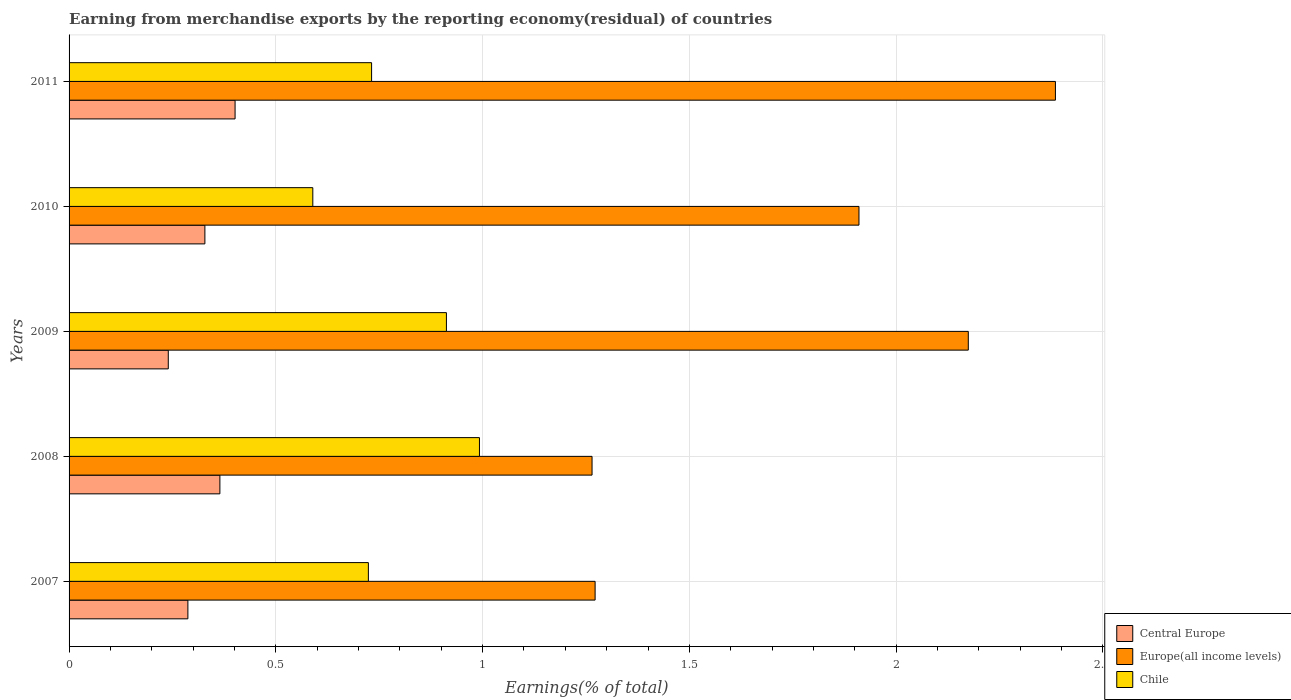How many different coloured bars are there?
Keep it short and to the point. 3. How many groups of bars are there?
Provide a short and direct response. 5. Are the number of bars on each tick of the Y-axis equal?
Ensure brevity in your answer.  Yes. How many bars are there on the 3rd tick from the bottom?
Provide a succinct answer. 3. What is the percentage of amount earned from merchandise exports in Europe(all income levels) in 2008?
Offer a very short reply. 1.26. Across all years, what is the maximum percentage of amount earned from merchandise exports in Central Europe?
Offer a terse response. 0.4. Across all years, what is the minimum percentage of amount earned from merchandise exports in Europe(all income levels)?
Give a very brief answer. 1.26. In which year was the percentage of amount earned from merchandise exports in Central Europe maximum?
Keep it short and to the point. 2011. In which year was the percentage of amount earned from merchandise exports in Central Europe minimum?
Provide a short and direct response. 2009. What is the total percentage of amount earned from merchandise exports in Central Europe in the graph?
Offer a very short reply. 1.62. What is the difference between the percentage of amount earned from merchandise exports in Europe(all income levels) in 2009 and that in 2010?
Offer a terse response. 0.26. What is the difference between the percentage of amount earned from merchandise exports in Europe(all income levels) in 2010 and the percentage of amount earned from merchandise exports in Chile in 2008?
Make the answer very short. 0.92. What is the average percentage of amount earned from merchandise exports in Central Europe per year?
Your answer should be very brief. 0.32. In the year 2011, what is the difference between the percentage of amount earned from merchandise exports in Chile and percentage of amount earned from merchandise exports in Central Europe?
Offer a very short reply. 0.33. In how many years, is the percentage of amount earned from merchandise exports in Europe(all income levels) greater than 0.7 %?
Make the answer very short. 5. What is the ratio of the percentage of amount earned from merchandise exports in Europe(all income levels) in 2009 to that in 2010?
Your response must be concise. 1.14. Is the percentage of amount earned from merchandise exports in Central Europe in 2009 less than that in 2010?
Provide a short and direct response. Yes. What is the difference between the highest and the second highest percentage of amount earned from merchandise exports in Central Europe?
Your answer should be compact. 0.04. What is the difference between the highest and the lowest percentage of amount earned from merchandise exports in Europe(all income levels)?
Ensure brevity in your answer.  1.12. In how many years, is the percentage of amount earned from merchandise exports in Central Europe greater than the average percentage of amount earned from merchandise exports in Central Europe taken over all years?
Keep it short and to the point. 3. Is the sum of the percentage of amount earned from merchandise exports in Chile in 2010 and 2011 greater than the maximum percentage of amount earned from merchandise exports in Europe(all income levels) across all years?
Your response must be concise. No. What does the 1st bar from the top in 2011 represents?
Keep it short and to the point. Chile. What does the 2nd bar from the bottom in 2007 represents?
Keep it short and to the point. Europe(all income levels). Is it the case that in every year, the sum of the percentage of amount earned from merchandise exports in Europe(all income levels) and percentage of amount earned from merchandise exports in Chile is greater than the percentage of amount earned from merchandise exports in Central Europe?
Give a very brief answer. Yes. Are all the bars in the graph horizontal?
Give a very brief answer. Yes. Are the values on the major ticks of X-axis written in scientific E-notation?
Ensure brevity in your answer.  No. How many legend labels are there?
Offer a terse response. 3. What is the title of the graph?
Ensure brevity in your answer.  Earning from merchandise exports by the reporting economy(residual) of countries. What is the label or title of the X-axis?
Ensure brevity in your answer.  Earnings(% of total). What is the label or title of the Y-axis?
Keep it short and to the point. Years. What is the Earnings(% of total) of Central Europe in 2007?
Provide a succinct answer. 0.29. What is the Earnings(% of total) in Europe(all income levels) in 2007?
Offer a very short reply. 1.27. What is the Earnings(% of total) of Chile in 2007?
Offer a terse response. 0.72. What is the Earnings(% of total) of Central Europe in 2008?
Keep it short and to the point. 0.36. What is the Earnings(% of total) of Europe(all income levels) in 2008?
Give a very brief answer. 1.26. What is the Earnings(% of total) in Chile in 2008?
Offer a terse response. 0.99. What is the Earnings(% of total) of Central Europe in 2009?
Give a very brief answer. 0.24. What is the Earnings(% of total) in Europe(all income levels) in 2009?
Your response must be concise. 2.17. What is the Earnings(% of total) in Chile in 2009?
Offer a very short reply. 0.91. What is the Earnings(% of total) in Central Europe in 2010?
Offer a terse response. 0.33. What is the Earnings(% of total) of Europe(all income levels) in 2010?
Provide a succinct answer. 1.91. What is the Earnings(% of total) of Chile in 2010?
Offer a very short reply. 0.59. What is the Earnings(% of total) of Central Europe in 2011?
Offer a terse response. 0.4. What is the Earnings(% of total) of Europe(all income levels) in 2011?
Ensure brevity in your answer.  2.39. What is the Earnings(% of total) in Chile in 2011?
Offer a very short reply. 0.73. Across all years, what is the maximum Earnings(% of total) in Central Europe?
Offer a very short reply. 0.4. Across all years, what is the maximum Earnings(% of total) of Europe(all income levels)?
Offer a terse response. 2.39. Across all years, what is the maximum Earnings(% of total) in Chile?
Keep it short and to the point. 0.99. Across all years, what is the minimum Earnings(% of total) in Central Europe?
Your answer should be very brief. 0.24. Across all years, what is the minimum Earnings(% of total) in Europe(all income levels)?
Provide a short and direct response. 1.26. Across all years, what is the minimum Earnings(% of total) of Chile?
Offer a terse response. 0.59. What is the total Earnings(% of total) in Central Europe in the graph?
Your answer should be very brief. 1.62. What is the total Earnings(% of total) of Europe(all income levels) in the graph?
Make the answer very short. 9.01. What is the total Earnings(% of total) in Chile in the graph?
Offer a terse response. 3.95. What is the difference between the Earnings(% of total) of Central Europe in 2007 and that in 2008?
Your answer should be compact. -0.08. What is the difference between the Earnings(% of total) in Europe(all income levels) in 2007 and that in 2008?
Keep it short and to the point. 0.01. What is the difference between the Earnings(% of total) of Chile in 2007 and that in 2008?
Make the answer very short. -0.27. What is the difference between the Earnings(% of total) of Central Europe in 2007 and that in 2009?
Your answer should be compact. 0.05. What is the difference between the Earnings(% of total) in Europe(all income levels) in 2007 and that in 2009?
Ensure brevity in your answer.  -0.9. What is the difference between the Earnings(% of total) in Chile in 2007 and that in 2009?
Provide a succinct answer. -0.19. What is the difference between the Earnings(% of total) of Central Europe in 2007 and that in 2010?
Provide a short and direct response. -0.04. What is the difference between the Earnings(% of total) of Europe(all income levels) in 2007 and that in 2010?
Make the answer very short. -0.64. What is the difference between the Earnings(% of total) of Chile in 2007 and that in 2010?
Ensure brevity in your answer.  0.13. What is the difference between the Earnings(% of total) in Central Europe in 2007 and that in 2011?
Your answer should be very brief. -0.11. What is the difference between the Earnings(% of total) of Europe(all income levels) in 2007 and that in 2011?
Give a very brief answer. -1.11. What is the difference between the Earnings(% of total) in Chile in 2007 and that in 2011?
Your answer should be compact. -0.01. What is the difference between the Earnings(% of total) in Central Europe in 2008 and that in 2009?
Your answer should be very brief. 0.12. What is the difference between the Earnings(% of total) of Europe(all income levels) in 2008 and that in 2009?
Your answer should be very brief. -0.91. What is the difference between the Earnings(% of total) in Chile in 2008 and that in 2009?
Ensure brevity in your answer.  0.08. What is the difference between the Earnings(% of total) in Central Europe in 2008 and that in 2010?
Offer a very short reply. 0.04. What is the difference between the Earnings(% of total) in Europe(all income levels) in 2008 and that in 2010?
Keep it short and to the point. -0.65. What is the difference between the Earnings(% of total) of Chile in 2008 and that in 2010?
Your response must be concise. 0.4. What is the difference between the Earnings(% of total) in Central Europe in 2008 and that in 2011?
Provide a succinct answer. -0.04. What is the difference between the Earnings(% of total) of Europe(all income levels) in 2008 and that in 2011?
Ensure brevity in your answer.  -1.12. What is the difference between the Earnings(% of total) in Chile in 2008 and that in 2011?
Offer a very short reply. 0.26. What is the difference between the Earnings(% of total) of Central Europe in 2009 and that in 2010?
Keep it short and to the point. -0.09. What is the difference between the Earnings(% of total) in Europe(all income levels) in 2009 and that in 2010?
Provide a succinct answer. 0.26. What is the difference between the Earnings(% of total) of Chile in 2009 and that in 2010?
Provide a succinct answer. 0.32. What is the difference between the Earnings(% of total) in Central Europe in 2009 and that in 2011?
Your response must be concise. -0.16. What is the difference between the Earnings(% of total) in Europe(all income levels) in 2009 and that in 2011?
Ensure brevity in your answer.  -0.21. What is the difference between the Earnings(% of total) in Chile in 2009 and that in 2011?
Ensure brevity in your answer.  0.18. What is the difference between the Earnings(% of total) of Central Europe in 2010 and that in 2011?
Provide a succinct answer. -0.07. What is the difference between the Earnings(% of total) in Europe(all income levels) in 2010 and that in 2011?
Offer a very short reply. -0.48. What is the difference between the Earnings(% of total) in Chile in 2010 and that in 2011?
Your response must be concise. -0.14. What is the difference between the Earnings(% of total) of Central Europe in 2007 and the Earnings(% of total) of Europe(all income levels) in 2008?
Your answer should be very brief. -0.98. What is the difference between the Earnings(% of total) in Central Europe in 2007 and the Earnings(% of total) in Chile in 2008?
Offer a very short reply. -0.71. What is the difference between the Earnings(% of total) of Europe(all income levels) in 2007 and the Earnings(% of total) of Chile in 2008?
Give a very brief answer. 0.28. What is the difference between the Earnings(% of total) of Central Europe in 2007 and the Earnings(% of total) of Europe(all income levels) in 2009?
Offer a terse response. -1.89. What is the difference between the Earnings(% of total) in Central Europe in 2007 and the Earnings(% of total) in Chile in 2009?
Offer a terse response. -0.63. What is the difference between the Earnings(% of total) of Europe(all income levels) in 2007 and the Earnings(% of total) of Chile in 2009?
Give a very brief answer. 0.36. What is the difference between the Earnings(% of total) of Central Europe in 2007 and the Earnings(% of total) of Europe(all income levels) in 2010?
Provide a succinct answer. -1.62. What is the difference between the Earnings(% of total) of Central Europe in 2007 and the Earnings(% of total) of Chile in 2010?
Your answer should be compact. -0.3. What is the difference between the Earnings(% of total) in Europe(all income levels) in 2007 and the Earnings(% of total) in Chile in 2010?
Offer a very short reply. 0.68. What is the difference between the Earnings(% of total) in Central Europe in 2007 and the Earnings(% of total) in Europe(all income levels) in 2011?
Your response must be concise. -2.1. What is the difference between the Earnings(% of total) in Central Europe in 2007 and the Earnings(% of total) in Chile in 2011?
Provide a succinct answer. -0.44. What is the difference between the Earnings(% of total) of Europe(all income levels) in 2007 and the Earnings(% of total) of Chile in 2011?
Your answer should be very brief. 0.54. What is the difference between the Earnings(% of total) in Central Europe in 2008 and the Earnings(% of total) in Europe(all income levels) in 2009?
Your response must be concise. -1.81. What is the difference between the Earnings(% of total) in Central Europe in 2008 and the Earnings(% of total) in Chile in 2009?
Offer a terse response. -0.55. What is the difference between the Earnings(% of total) in Europe(all income levels) in 2008 and the Earnings(% of total) in Chile in 2009?
Your response must be concise. 0.35. What is the difference between the Earnings(% of total) of Central Europe in 2008 and the Earnings(% of total) of Europe(all income levels) in 2010?
Offer a very short reply. -1.55. What is the difference between the Earnings(% of total) in Central Europe in 2008 and the Earnings(% of total) in Chile in 2010?
Ensure brevity in your answer.  -0.22. What is the difference between the Earnings(% of total) of Europe(all income levels) in 2008 and the Earnings(% of total) of Chile in 2010?
Make the answer very short. 0.68. What is the difference between the Earnings(% of total) in Central Europe in 2008 and the Earnings(% of total) in Europe(all income levels) in 2011?
Ensure brevity in your answer.  -2.02. What is the difference between the Earnings(% of total) of Central Europe in 2008 and the Earnings(% of total) of Chile in 2011?
Make the answer very short. -0.37. What is the difference between the Earnings(% of total) in Europe(all income levels) in 2008 and the Earnings(% of total) in Chile in 2011?
Give a very brief answer. 0.53. What is the difference between the Earnings(% of total) of Central Europe in 2009 and the Earnings(% of total) of Europe(all income levels) in 2010?
Your response must be concise. -1.67. What is the difference between the Earnings(% of total) in Central Europe in 2009 and the Earnings(% of total) in Chile in 2010?
Offer a terse response. -0.35. What is the difference between the Earnings(% of total) of Europe(all income levels) in 2009 and the Earnings(% of total) of Chile in 2010?
Make the answer very short. 1.59. What is the difference between the Earnings(% of total) of Central Europe in 2009 and the Earnings(% of total) of Europe(all income levels) in 2011?
Provide a succinct answer. -2.15. What is the difference between the Earnings(% of total) of Central Europe in 2009 and the Earnings(% of total) of Chile in 2011?
Your response must be concise. -0.49. What is the difference between the Earnings(% of total) of Europe(all income levels) in 2009 and the Earnings(% of total) of Chile in 2011?
Provide a short and direct response. 1.44. What is the difference between the Earnings(% of total) of Central Europe in 2010 and the Earnings(% of total) of Europe(all income levels) in 2011?
Provide a succinct answer. -2.06. What is the difference between the Earnings(% of total) of Central Europe in 2010 and the Earnings(% of total) of Chile in 2011?
Give a very brief answer. -0.4. What is the difference between the Earnings(% of total) of Europe(all income levels) in 2010 and the Earnings(% of total) of Chile in 2011?
Your answer should be compact. 1.18. What is the average Earnings(% of total) in Central Europe per year?
Provide a short and direct response. 0.32. What is the average Earnings(% of total) in Europe(all income levels) per year?
Ensure brevity in your answer.  1.8. What is the average Earnings(% of total) of Chile per year?
Offer a terse response. 0.79. In the year 2007, what is the difference between the Earnings(% of total) in Central Europe and Earnings(% of total) in Europe(all income levels)?
Keep it short and to the point. -0.98. In the year 2007, what is the difference between the Earnings(% of total) in Central Europe and Earnings(% of total) in Chile?
Your answer should be very brief. -0.44. In the year 2007, what is the difference between the Earnings(% of total) of Europe(all income levels) and Earnings(% of total) of Chile?
Give a very brief answer. 0.55. In the year 2008, what is the difference between the Earnings(% of total) of Central Europe and Earnings(% of total) of Europe(all income levels)?
Your response must be concise. -0.9. In the year 2008, what is the difference between the Earnings(% of total) in Central Europe and Earnings(% of total) in Chile?
Give a very brief answer. -0.63. In the year 2008, what is the difference between the Earnings(% of total) of Europe(all income levels) and Earnings(% of total) of Chile?
Your response must be concise. 0.27. In the year 2009, what is the difference between the Earnings(% of total) of Central Europe and Earnings(% of total) of Europe(all income levels)?
Give a very brief answer. -1.93. In the year 2009, what is the difference between the Earnings(% of total) in Central Europe and Earnings(% of total) in Chile?
Your answer should be compact. -0.67. In the year 2009, what is the difference between the Earnings(% of total) in Europe(all income levels) and Earnings(% of total) in Chile?
Provide a short and direct response. 1.26. In the year 2010, what is the difference between the Earnings(% of total) in Central Europe and Earnings(% of total) in Europe(all income levels)?
Offer a terse response. -1.58. In the year 2010, what is the difference between the Earnings(% of total) of Central Europe and Earnings(% of total) of Chile?
Keep it short and to the point. -0.26. In the year 2010, what is the difference between the Earnings(% of total) of Europe(all income levels) and Earnings(% of total) of Chile?
Your answer should be very brief. 1.32. In the year 2011, what is the difference between the Earnings(% of total) in Central Europe and Earnings(% of total) in Europe(all income levels)?
Make the answer very short. -1.98. In the year 2011, what is the difference between the Earnings(% of total) in Central Europe and Earnings(% of total) in Chile?
Your response must be concise. -0.33. In the year 2011, what is the difference between the Earnings(% of total) in Europe(all income levels) and Earnings(% of total) in Chile?
Provide a succinct answer. 1.65. What is the ratio of the Earnings(% of total) of Central Europe in 2007 to that in 2008?
Provide a short and direct response. 0.79. What is the ratio of the Earnings(% of total) of Europe(all income levels) in 2007 to that in 2008?
Your answer should be very brief. 1.01. What is the ratio of the Earnings(% of total) in Chile in 2007 to that in 2008?
Your response must be concise. 0.73. What is the ratio of the Earnings(% of total) in Central Europe in 2007 to that in 2009?
Ensure brevity in your answer.  1.2. What is the ratio of the Earnings(% of total) of Europe(all income levels) in 2007 to that in 2009?
Offer a very short reply. 0.58. What is the ratio of the Earnings(% of total) in Chile in 2007 to that in 2009?
Your answer should be very brief. 0.79. What is the ratio of the Earnings(% of total) of Central Europe in 2007 to that in 2010?
Give a very brief answer. 0.87. What is the ratio of the Earnings(% of total) in Europe(all income levels) in 2007 to that in 2010?
Your answer should be compact. 0.67. What is the ratio of the Earnings(% of total) of Chile in 2007 to that in 2010?
Offer a very short reply. 1.23. What is the ratio of the Earnings(% of total) of Central Europe in 2007 to that in 2011?
Offer a terse response. 0.72. What is the ratio of the Earnings(% of total) of Europe(all income levels) in 2007 to that in 2011?
Offer a very short reply. 0.53. What is the ratio of the Earnings(% of total) in Chile in 2007 to that in 2011?
Your answer should be very brief. 0.99. What is the ratio of the Earnings(% of total) in Central Europe in 2008 to that in 2009?
Provide a succinct answer. 1.52. What is the ratio of the Earnings(% of total) of Europe(all income levels) in 2008 to that in 2009?
Provide a succinct answer. 0.58. What is the ratio of the Earnings(% of total) of Chile in 2008 to that in 2009?
Keep it short and to the point. 1.09. What is the ratio of the Earnings(% of total) of Central Europe in 2008 to that in 2010?
Offer a terse response. 1.11. What is the ratio of the Earnings(% of total) in Europe(all income levels) in 2008 to that in 2010?
Provide a succinct answer. 0.66. What is the ratio of the Earnings(% of total) in Chile in 2008 to that in 2010?
Ensure brevity in your answer.  1.68. What is the ratio of the Earnings(% of total) in Central Europe in 2008 to that in 2011?
Your answer should be compact. 0.91. What is the ratio of the Earnings(% of total) in Europe(all income levels) in 2008 to that in 2011?
Your answer should be very brief. 0.53. What is the ratio of the Earnings(% of total) in Chile in 2008 to that in 2011?
Provide a succinct answer. 1.36. What is the ratio of the Earnings(% of total) in Central Europe in 2009 to that in 2010?
Your response must be concise. 0.73. What is the ratio of the Earnings(% of total) in Europe(all income levels) in 2009 to that in 2010?
Give a very brief answer. 1.14. What is the ratio of the Earnings(% of total) of Chile in 2009 to that in 2010?
Make the answer very short. 1.55. What is the ratio of the Earnings(% of total) in Central Europe in 2009 to that in 2011?
Your answer should be very brief. 0.6. What is the ratio of the Earnings(% of total) of Europe(all income levels) in 2009 to that in 2011?
Provide a succinct answer. 0.91. What is the ratio of the Earnings(% of total) in Chile in 2009 to that in 2011?
Your answer should be very brief. 1.25. What is the ratio of the Earnings(% of total) of Central Europe in 2010 to that in 2011?
Provide a succinct answer. 0.82. What is the ratio of the Earnings(% of total) in Europe(all income levels) in 2010 to that in 2011?
Offer a terse response. 0.8. What is the ratio of the Earnings(% of total) in Chile in 2010 to that in 2011?
Provide a succinct answer. 0.81. What is the difference between the highest and the second highest Earnings(% of total) of Central Europe?
Your answer should be compact. 0.04. What is the difference between the highest and the second highest Earnings(% of total) in Europe(all income levels)?
Make the answer very short. 0.21. What is the difference between the highest and the second highest Earnings(% of total) of Chile?
Give a very brief answer. 0.08. What is the difference between the highest and the lowest Earnings(% of total) of Central Europe?
Offer a very short reply. 0.16. What is the difference between the highest and the lowest Earnings(% of total) in Europe(all income levels)?
Your answer should be compact. 1.12. What is the difference between the highest and the lowest Earnings(% of total) of Chile?
Keep it short and to the point. 0.4. 